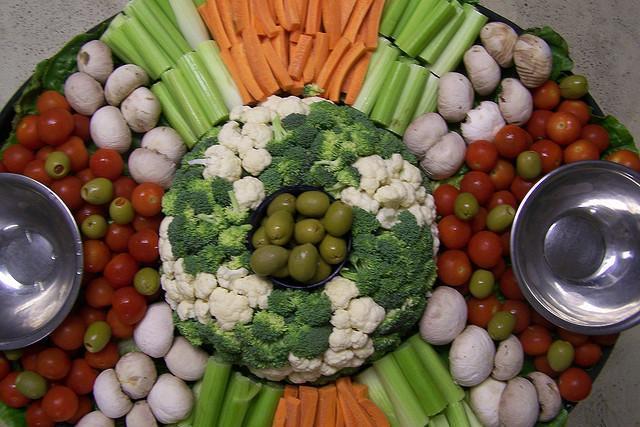How many broccolis are there?
Give a very brief answer. 4. How many bowls are visible?
Give a very brief answer. 2. How many carrots are there?
Give a very brief answer. 2. 